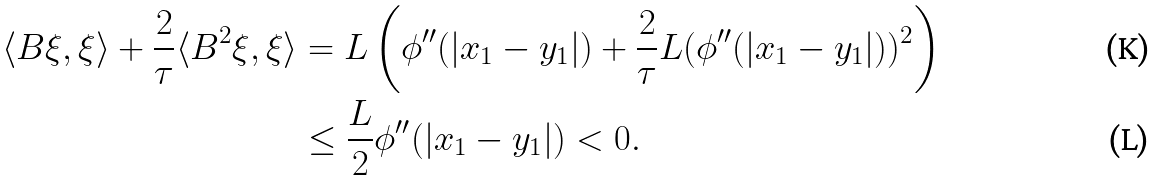<formula> <loc_0><loc_0><loc_500><loc_500>\langle B \xi , \xi \rangle + \frac { 2 } { \tau } \langle B ^ { 2 } \xi , \xi \rangle & = L \left ( \phi ^ { \prime \prime } ( | x _ { 1 } - y _ { 1 } | ) + \frac { 2 } { \tau } L ( \phi ^ { \prime \prime } ( | x _ { 1 } - y _ { 1 } | ) ) ^ { 2 } \right ) \\ & \leq \frac { L } { 2 } \phi ^ { \prime \prime } ( | x _ { 1 } - y _ { 1 } | ) < 0 .</formula> 